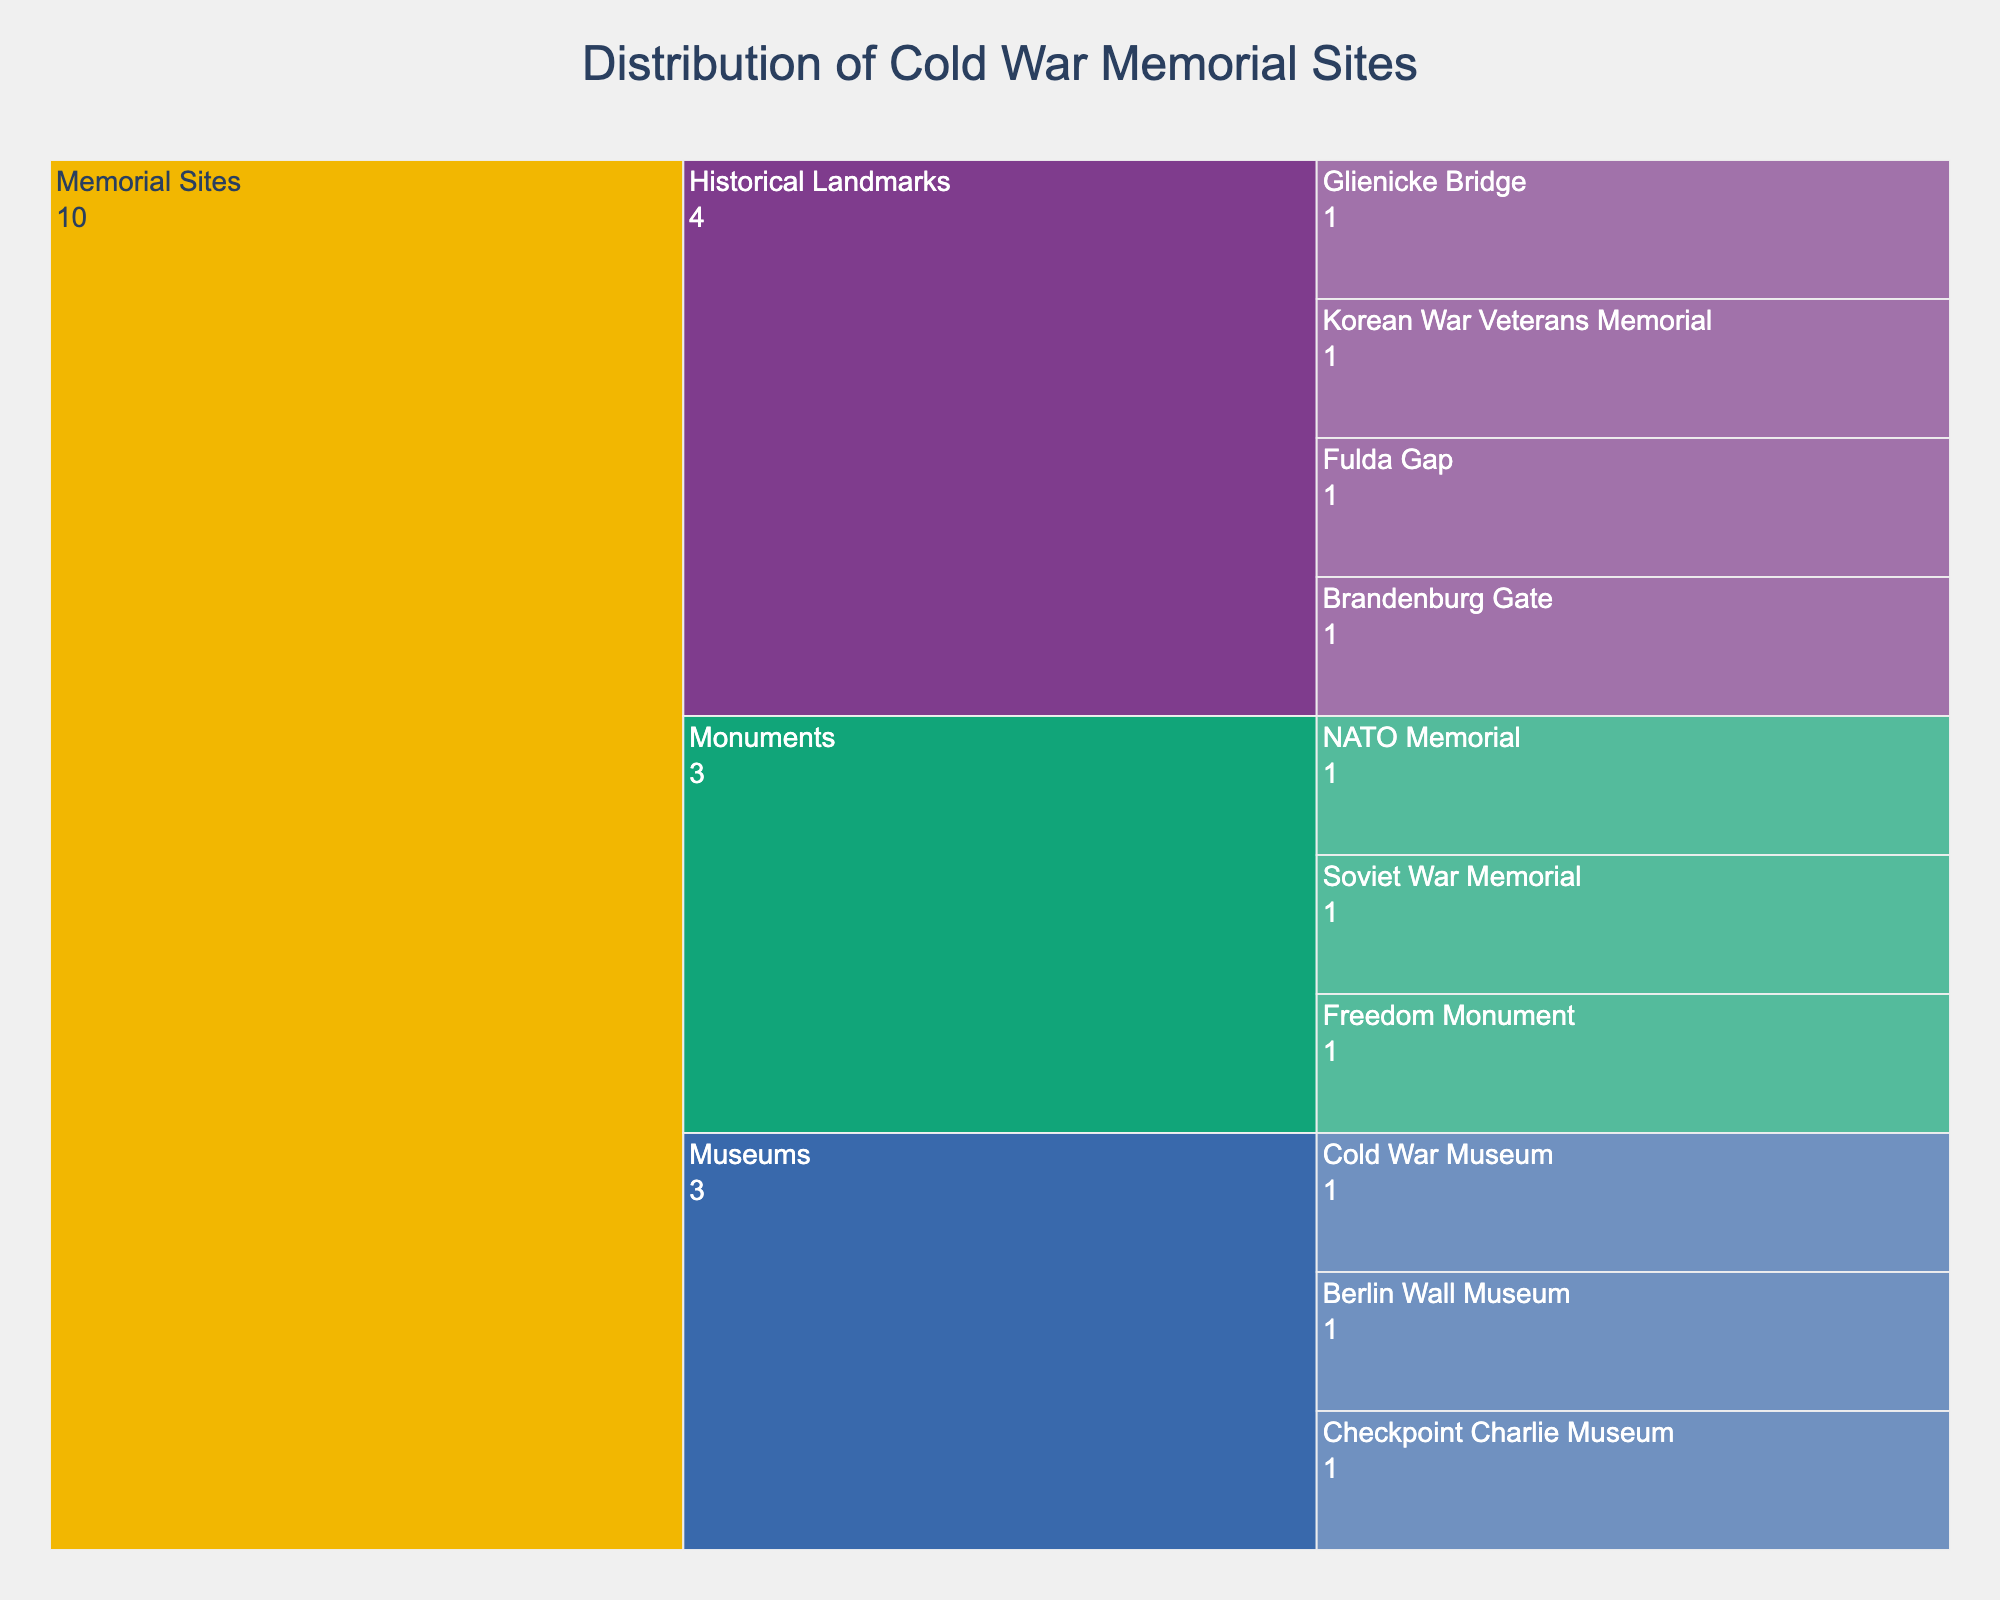What is the title of the icicle chart? The title is usually located at the top of the chart; in this case, it reads 'Distribution of Cold War Memorial Sites.'
Answer: Distribution of Cold War Memorial Sites What category has the most sites listed? Count the number of sites for each category. Historical Landmarks have four sites listed, Museums have three, and Monuments have three.
Answer: Historical Landmarks How many Cold War museums are listed in the chart? Under the Museums category, list out the number of sites: Cold War Museum, Berlin Wall Museum, Checkpoint Charlie Museum. This totals to three.
Answer: 3 Which monument is featured in the chart? Look under the Monuments category and list all the sites: Freedom Monument, Soviet War Memorial, NATO Memorial.
Answer: Freedom Monument, Soviet War Memorial, NATO Memorial How many types of Cold War memorial sites are shown in the chart? Identify all unique types at the top level of categories: Memorial Sites is the only type listed.
Answer: 1 What is the total number of historical landmarks listed? Count the number of sites under the Historical Landmarks category: Brandenburg Gate, Fulda Gap, Glienicke Bridge, Korean War Veterans Memorial. This totals to four.
Answer: 4 Compare the number of museums and monuments. Which one has more sites listed? Count the number of sites under Museums (three) and Monuments (three) to compare. Therefore, both categories have an equal number of sites.
Answer: Equal number Among the historical landmarks, which site is related to the Korean War? Inspect the list of historical landmarks and identify the one related to the Korean War: the Korean War Veterans Memorial.
Answer: Korean War Veterans Memorial Which categorical segment shows the greatest color difference? Assess the chart to visually identify which categories use distinct colors; these are typically different between the top- and second-level categories. Historical Landmarks, Museums, and Monuments will each be distinctly colored.
Answer: Historical Landmarks, Museums, and Monuments What proportion of the Cold War memorial sites are historical landmarks in the region? Count the total number of sites (10) then count the number of historical landmarks (4). The proportion is found by dividing the number of landmarks by the total number of sites: 4/10 or 40%.
Answer: 40% 